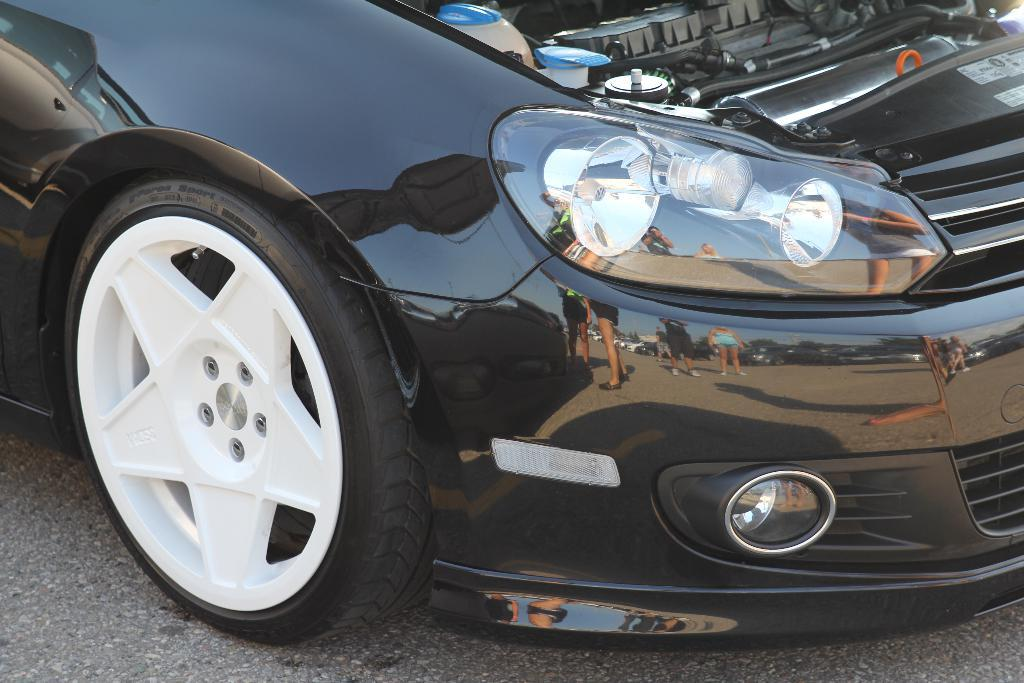What is the main subject of the image? The main subject of the image is a car. Can you describe the color of the car? The car is black in color. What else can be observed on the car in the image? There are reflected images of persons on the car. How many cows can be seen grazing near the car in the image? There are no cows present in the image; it only features a black car with reflected images of persons. Can you tell me how the car is moving in the image? The car is not moving in the image; it is stationary, and the focus is on the reflected images of persons. 